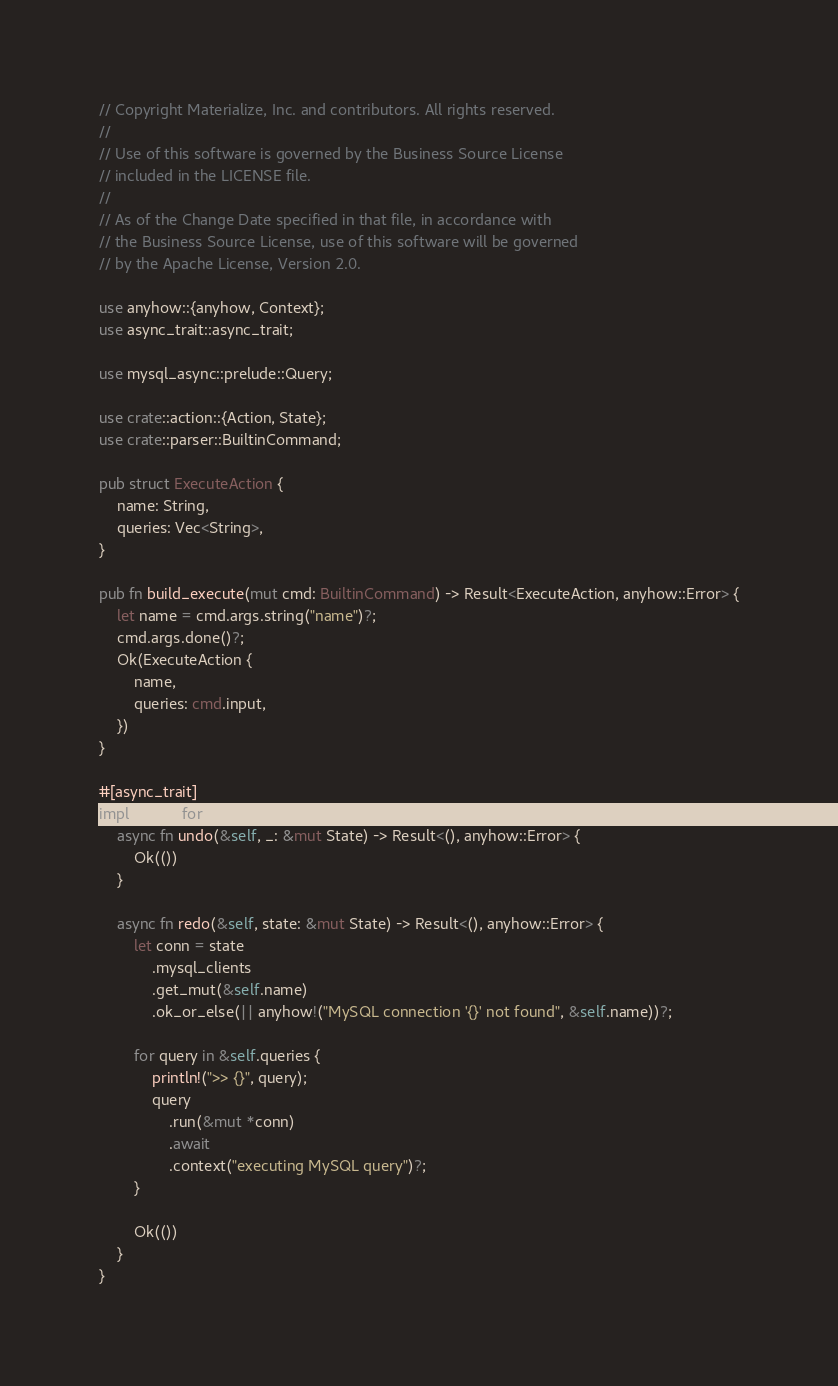Convert code to text. <code><loc_0><loc_0><loc_500><loc_500><_Rust_>// Copyright Materialize, Inc. and contributors. All rights reserved.
//
// Use of this software is governed by the Business Source License
// included in the LICENSE file.
//
// As of the Change Date specified in that file, in accordance with
// the Business Source License, use of this software will be governed
// by the Apache License, Version 2.0.

use anyhow::{anyhow, Context};
use async_trait::async_trait;

use mysql_async::prelude::Query;

use crate::action::{Action, State};
use crate::parser::BuiltinCommand;

pub struct ExecuteAction {
    name: String,
    queries: Vec<String>,
}

pub fn build_execute(mut cmd: BuiltinCommand) -> Result<ExecuteAction, anyhow::Error> {
    let name = cmd.args.string("name")?;
    cmd.args.done()?;
    Ok(ExecuteAction {
        name,
        queries: cmd.input,
    })
}

#[async_trait]
impl Action for ExecuteAction {
    async fn undo(&self, _: &mut State) -> Result<(), anyhow::Error> {
        Ok(())
    }

    async fn redo(&self, state: &mut State) -> Result<(), anyhow::Error> {
        let conn = state
            .mysql_clients
            .get_mut(&self.name)
            .ok_or_else(|| anyhow!("MySQL connection '{}' not found", &self.name))?;

        for query in &self.queries {
            println!(">> {}", query);
            query
                .run(&mut *conn)
                .await
                .context("executing MySQL query")?;
        }

        Ok(())
    }
}
</code> 